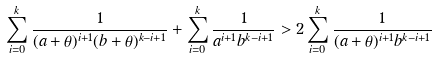<formula> <loc_0><loc_0><loc_500><loc_500>\sum _ { i = 0 } ^ { k } \frac { 1 } { ( { a } + \theta ) ^ { i + 1 } ( { b } + \theta ) ^ { k - i + 1 } } + \sum _ { i = 0 } ^ { k } \frac { 1 } { { a } ^ { i + 1 } { b } ^ { k - i + 1 } } > 2 \sum _ { i = 0 } ^ { k } \frac { 1 } { ( { a } + \theta ) ^ { i + 1 } { b } ^ { k - i + 1 } }</formula> 